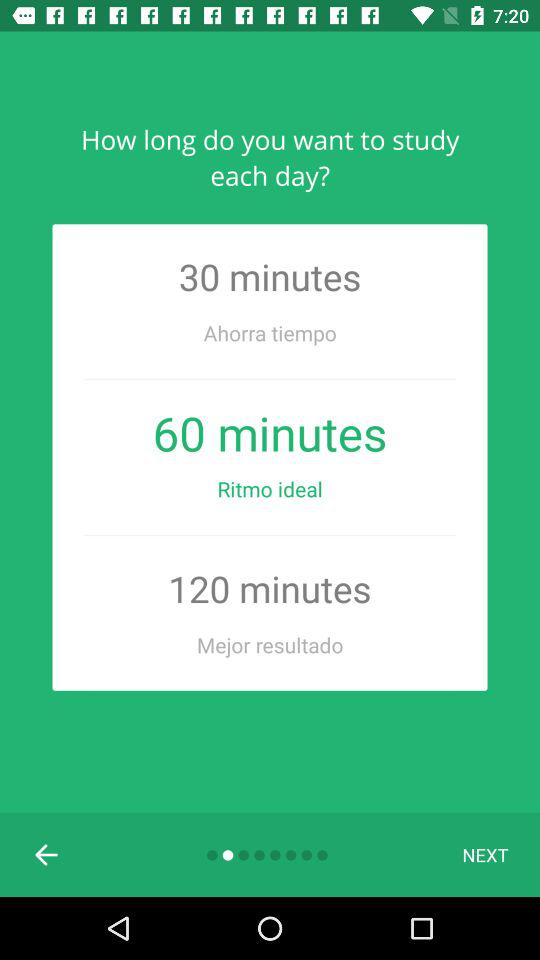How many study time options are there?
Answer the question using a single word or phrase. 3 